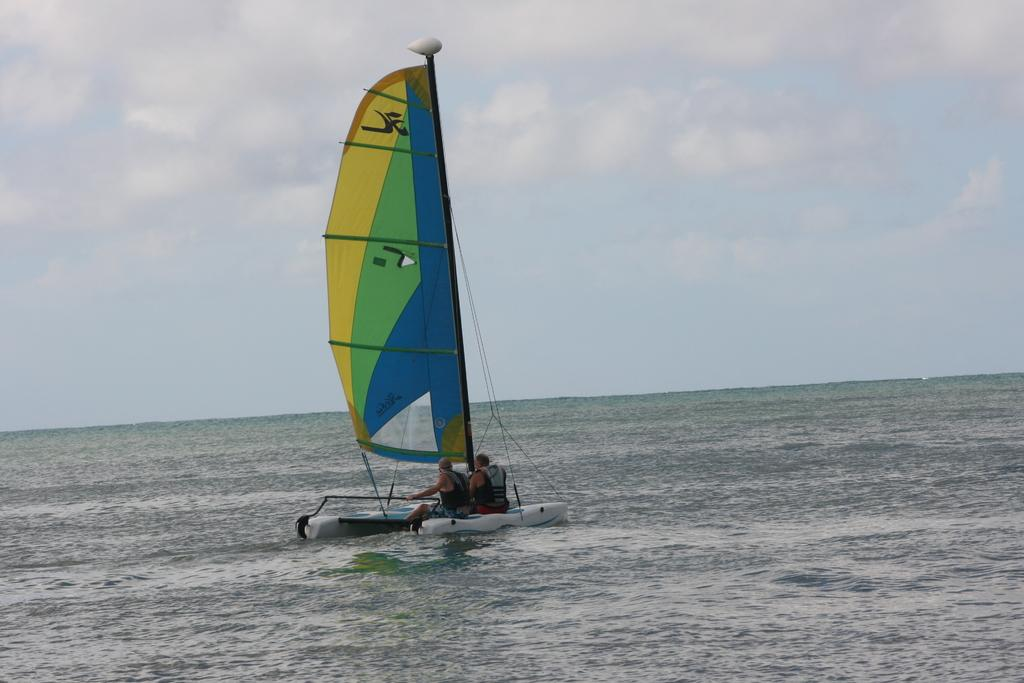What is the main subject of the image? The main subject of the image is water. What can be seen in the middle of the water? There is a boat in the middle of the water. How many people are in the boat? There are two persons in the boat. What is visible at the top of the image? The sky is visible at the top of the image. What type of metal is used to construct the bath in the image? There is no bath present in the image; it features water with a boat and two persons. What liquid is being poured from the metal container in the image? There is no metal container or liquid being poured in the image. 